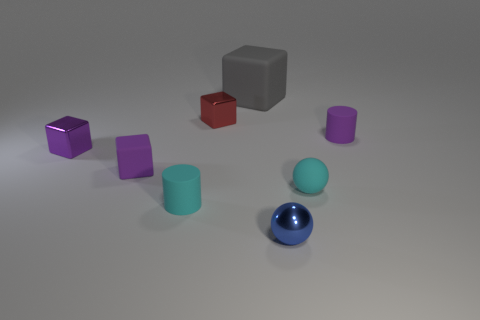There is a tiny rubber object behind the small matte cube; does it have the same shape as the cyan matte thing on the right side of the blue shiny object?
Your answer should be very brief. No. There is a metal thing that is both in front of the red object and on the right side of the small purple rubber block; how big is it?
Give a very brief answer. Small. There is another tiny shiny thing that is the same shape as the small purple metal thing; what is its color?
Provide a succinct answer. Red. What is the color of the metal cube that is in front of the tiny matte cylinder to the right of the large gray matte block?
Your answer should be compact. Purple. The large thing is what shape?
Keep it short and to the point. Cube. There is a matte object that is behind the small purple metal cube and on the right side of the big object; what is its shape?
Provide a succinct answer. Cylinder. There is a sphere that is made of the same material as the gray object; what color is it?
Your response must be concise. Cyan. The cyan rubber object to the right of the metal block right of the shiny cube in front of the small red metallic cube is what shape?
Give a very brief answer. Sphere. The blue sphere has what size?
Your answer should be compact. Small. There is a small purple thing that is the same material as the red object; what is its shape?
Make the answer very short. Cube. 